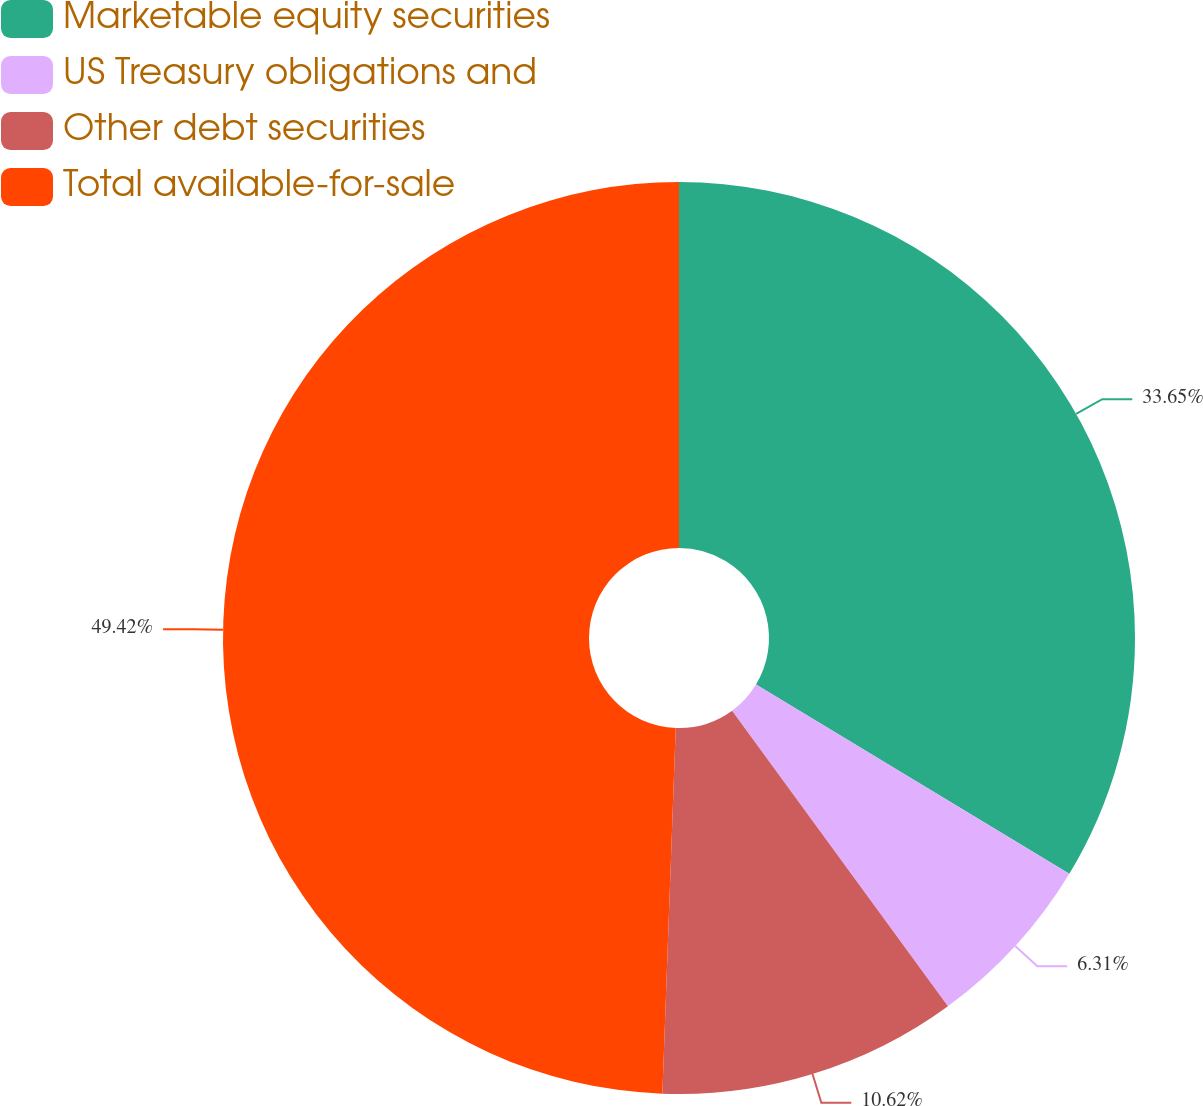<chart> <loc_0><loc_0><loc_500><loc_500><pie_chart><fcel>Marketable equity securities<fcel>US Treasury obligations and<fcel>Other debt securities<fcel>Total available-for-sale<nl><fcel>33.65%<fcel>6.31%<fcel>10.62%<fcel>49.42%<nl></chart> 